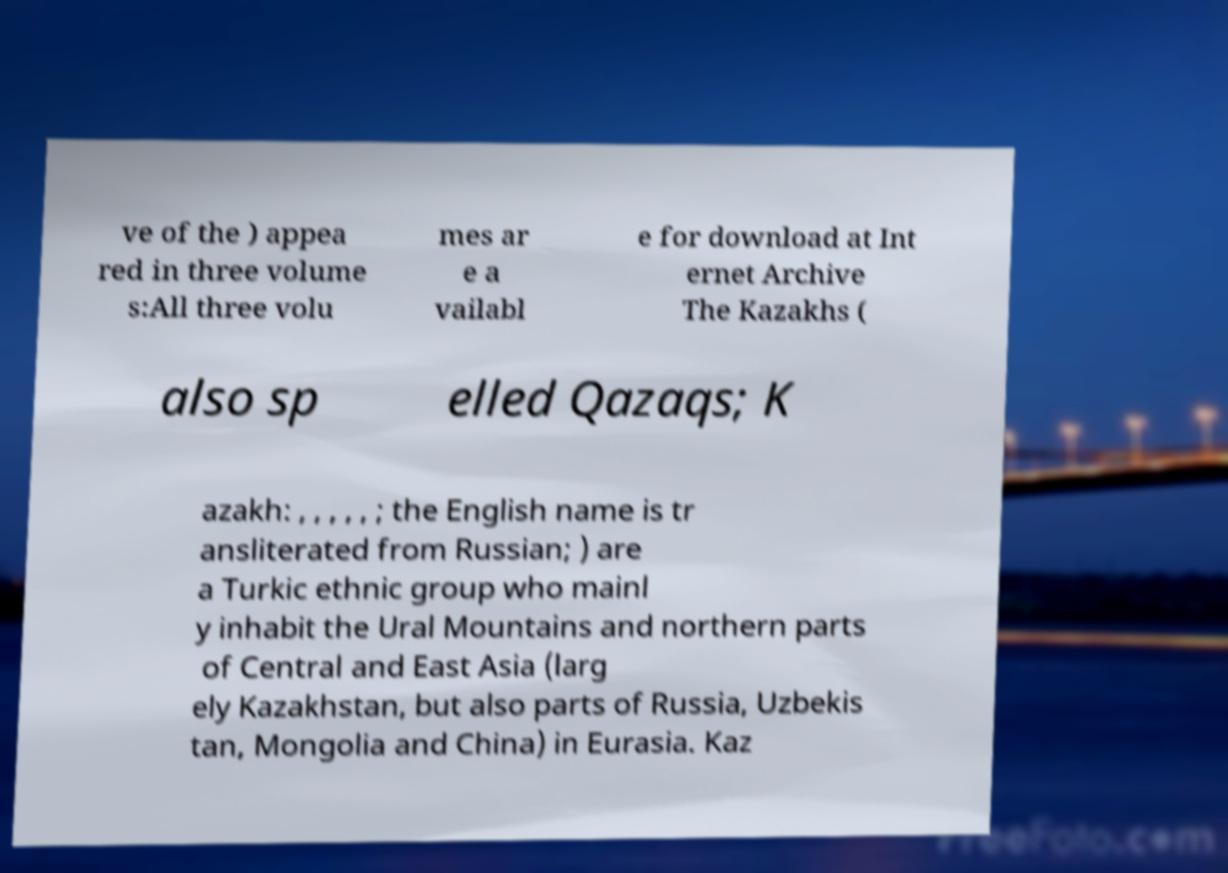Please read and relay the text visible in this image. What does it say? ve of the ) appea red in three volume s:All three volu mes ar e a vailabl e for download at Int ernet Archive The Kazakhs ( also sp elled Qazaqs; K azakh: , , , , , ; the English name is tr ansliterated from Russian; ) are a Turkic ethnic group who mainl y inhabit the Ural Mountains and northern parts of Central and East Asia (larg ely Kazakhstan, but also parts of Russia, Uzbekis tan, Mongolia and China) in Eurasia. Kaz 